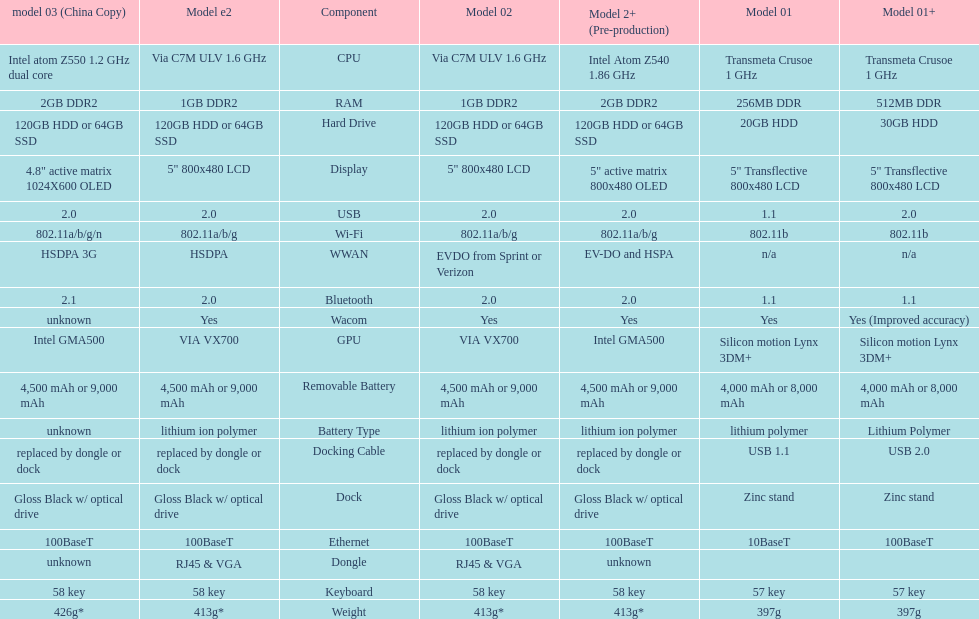How many models have 1.6ghz? 2. 